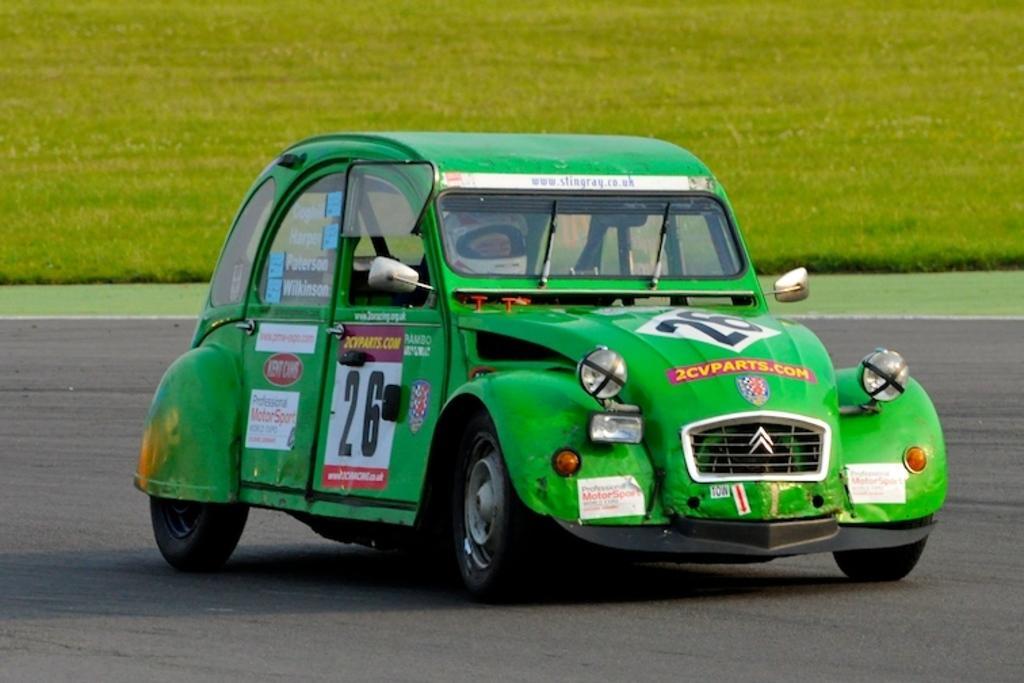Please provide a concise description of this image. In this image, we can see a person wearing a helmet and riding a car on the road. In the background, we can see grass. 